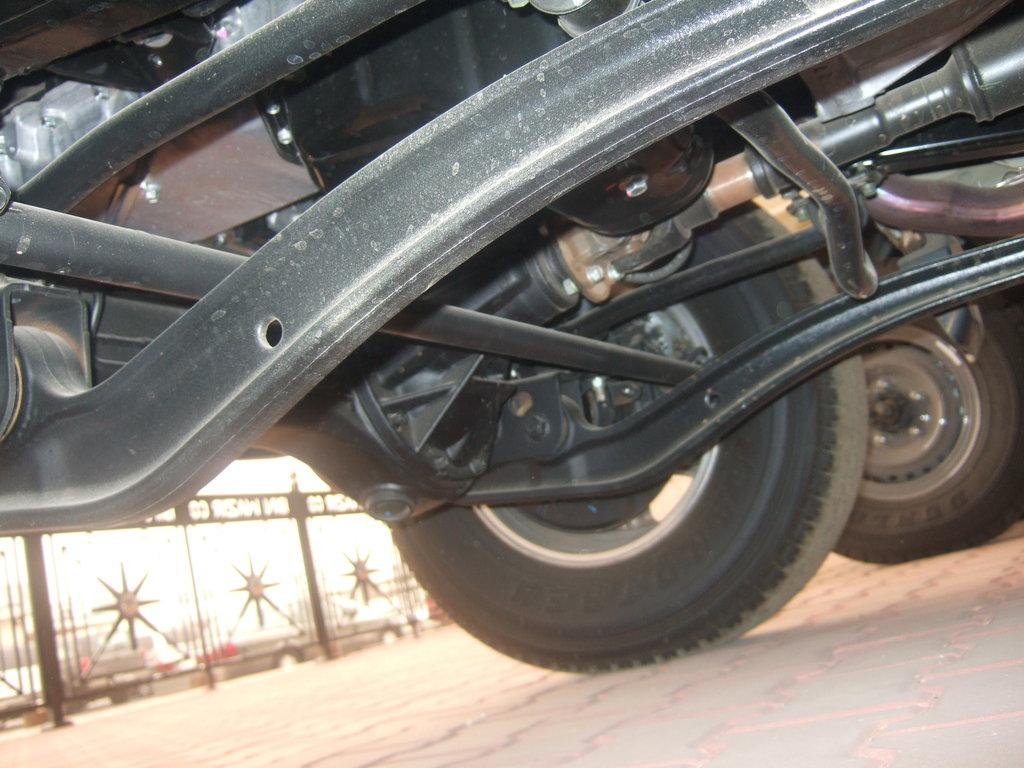What types of vehicles can be seen in the image? There are vehicles in the image, but the specific types are not mentioned. What is located on the left side of the image? There is a gate on the left side of the image. What can be seen at the bottom of the image? The road is visible at the bottom of the image. How many apples are being distributed in the image? There is no mention of apples or distribution in the image. 